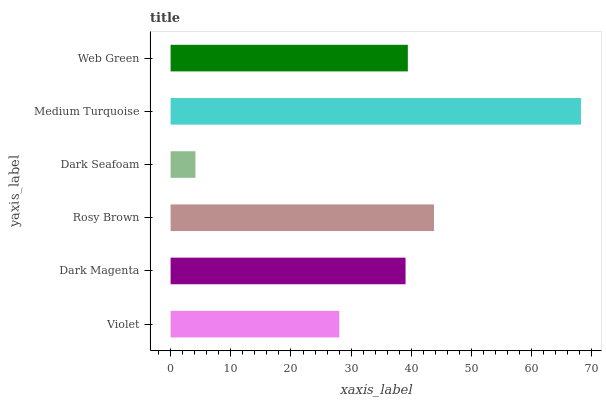Is Dark Seafoam the minimum?
Answer yes or no. Yes. Is Medium Turquoise the maximum?
Answer yes or no. Yes. Is Dark Magenta the minimum?
Answer yes or no. No. Is Dark Magenta the maximum?
Answer yes or no. No. Is Dark Magenta greater than Violet?
Answer yes or no. Yes. Is Violet less than Dark Magenta?
Answer yes or no. Yes. Is Violet greater than Dark Magenta?
Answer yes or no. No. Is Dark Magenta less than Violet?
Answer yes or no. No. Is Web Green the high median?
Answer yes or no. Yes. Is Dark Magenta the low median?
Answer yes or no. Yes. Is Medium Turquoise the high median?
Answer yes or no. No. Is Violet the low median?
Answer yes or no. No. 